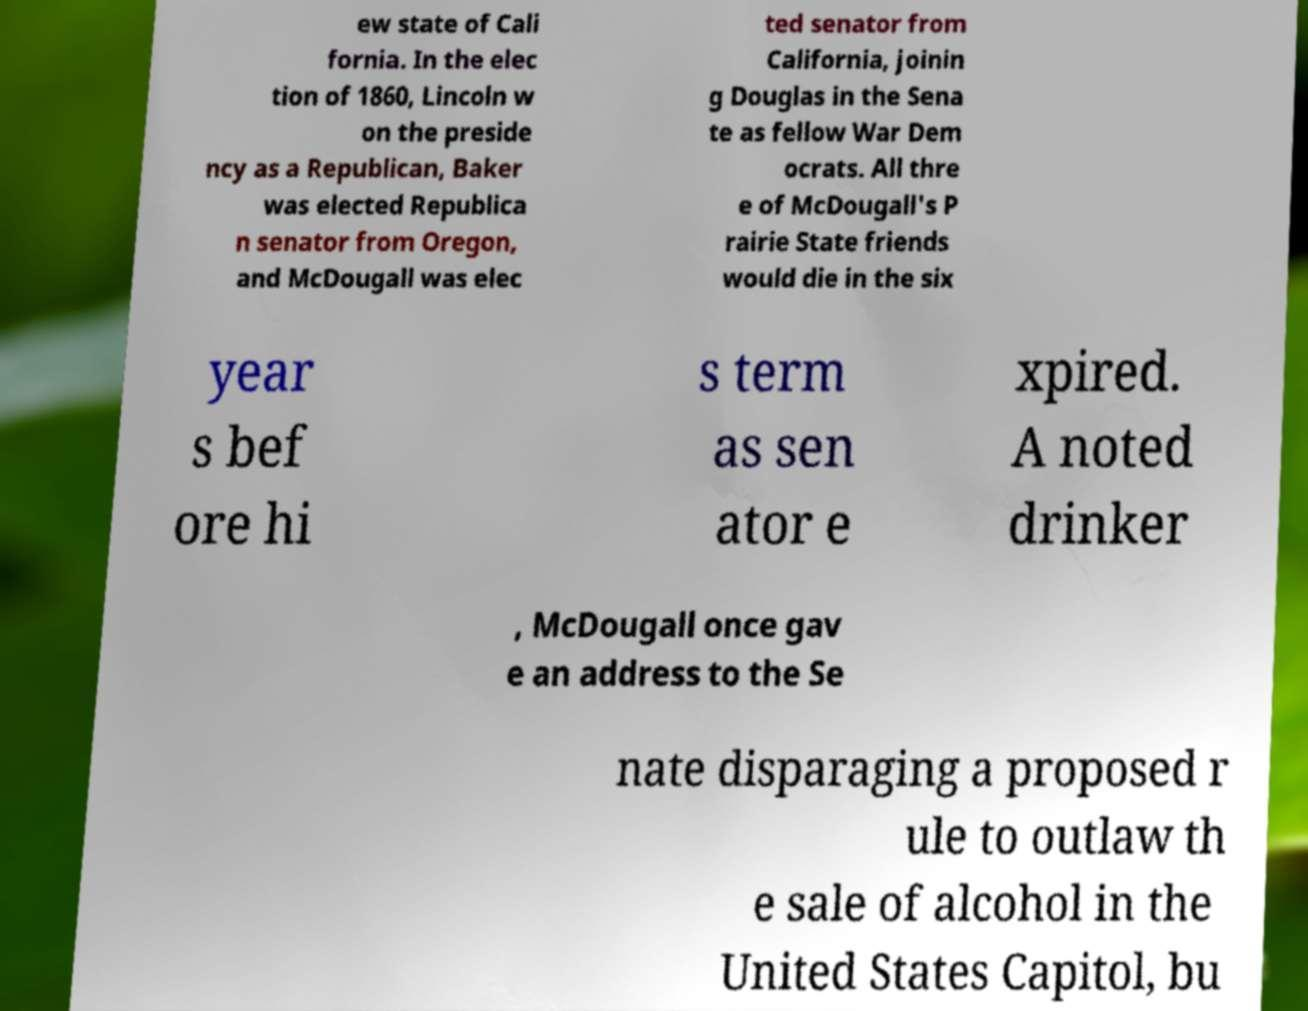Please identify and transcribe the text found in this image. ew state of Cali fornia. In the elec tion of 1860, Lincoln w on the preside ncy as a Republican, Baker was elected Republica n senator from Oregon, and McDougall was elec ted senator from California, joinin g Douglas in the Sena te as fellow War Dem ocrats. All thre e of McDougall's P rairie State friends would die in the six year s bef ore hi s term as sen ator e xpired. A noted drinker , McDougall once gav e an address to the Se nate disparaging a proposed r ule to outlaw th e sale of alcohol in the United States Capitol, bu 